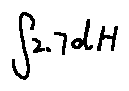Convert formula to latex. <formula><loc_0><loc_0><loc_500><loc_500>\int 2 . 7 d H</formula> 